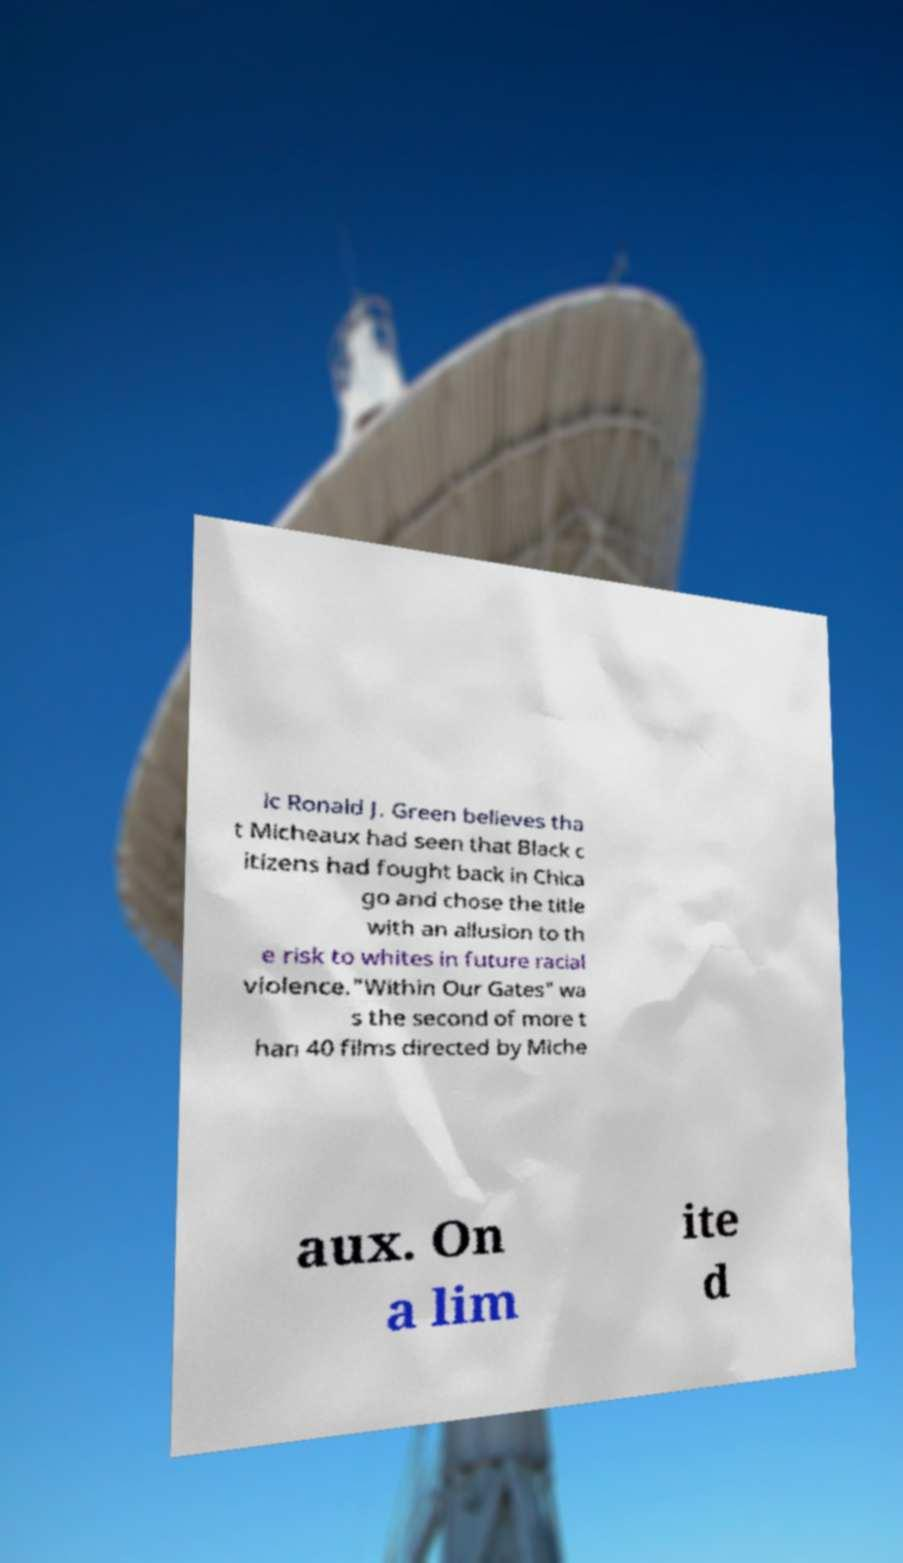Please identify and transcribe the text found in this image. ic Ronald J. Green believes tha t Micheaux had seen that Black c itizens had fought back in Chica go and chose the title with an allusion to th e risk to whites in future racial violence."Within Our Gates" wa s the second of more t han 40 films directed by Miche aux. On a lim ite d 